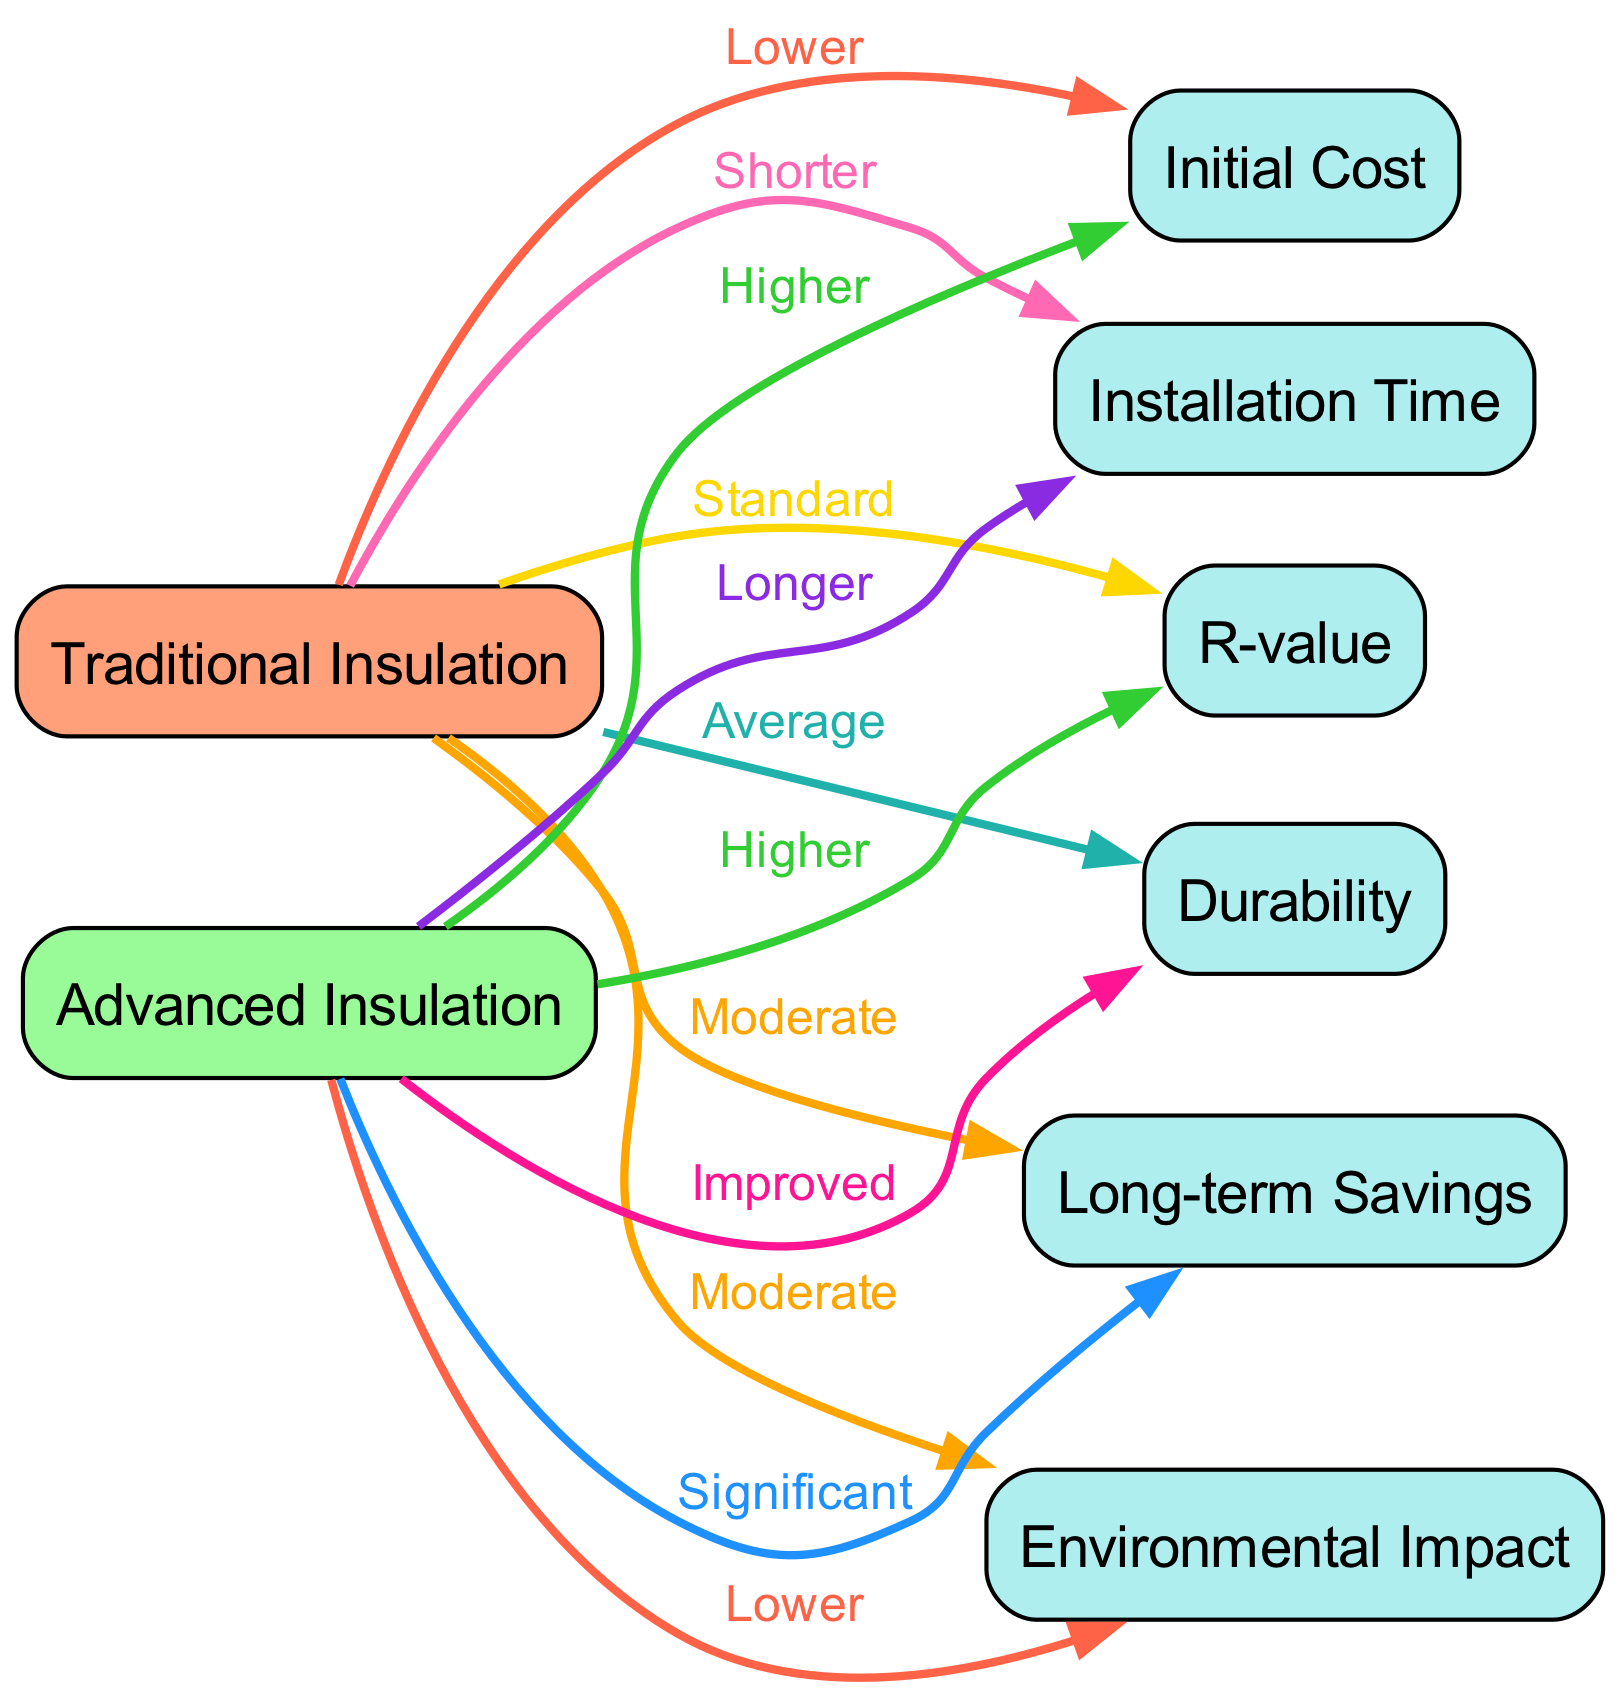What is the label of the node representing advanced insulation? The diagram clearly states the label of the node for advanced insulation, which is "Advanced Insulation."
Answer: Advanced Insulation How many nodes are there in the diagram? By counting all the distinct nodes listed in the data, there are a total of 8 nodes present in the diagram.
Answer: 8 What edge connects traditional insulation to long-term savings? The edge from traditional insulation to long-term savings is labeled "Moderate," indicating the comparative savings associated with traditional insulation.
Answer: Moderate What is the initial cost comparison between traditional and advanced insulation? The diagram shows that the initial cost of traditional insulation is labeled "Lower" compared to advanced insulation, which is labeled "Higher."
Answer: Lower Which insulation type has a higher R-value? The diagram indicates that advanced insulation has a "Higher" R-value when compared to the standard R-value of traditional insulation.
Answer: Higher What is the environmental impact of advanced insulation? The diagram states that the environmental impact of advanced insulation is labeled "Lower" in comparison to traditional insulation.
Answer: Lower What is the installation time for traditional insulation compared to advanced insulation? The relationship indicated in the diagram shows that the installation time for traditional insulation is labeled "Shorter" than that of advanced insulation, which is labeled "Longer."
Answer: Shorter Which insulation technology has improved durability? According to the diagram, advanced insulation is noted as having "Improved" durability compared to the average durability of traditional insulation.
Answer: Improved How do long-term savings compare between the two insulation types? The information in the diagram reveals that long-term savings for advanced insulation are labeled as "Significant," while traditional insulation's savings are labeled "Moderate."
Answer: Significant 